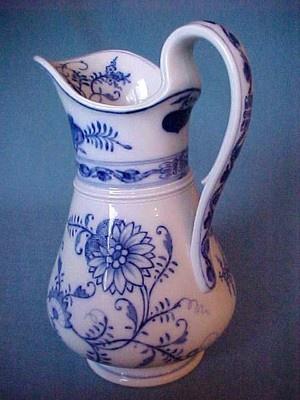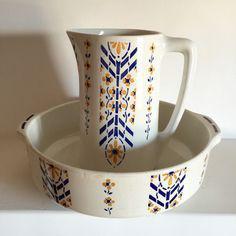The first image is the image on the left, the second image is the image on the right. For the images shown, is this caption "One of two bowl and pitcher sets is predominantly white with only a pattern on the upper edge of the pitcher and the bowl." true? Answer yes or no. No. The first image is the image on the left, the second image is the image on the right. Considering the images on both sides, is "At least one image includes a pitcher with a graceful curving handle instead of a squared one." valid? Answer yes or no. Yes. 